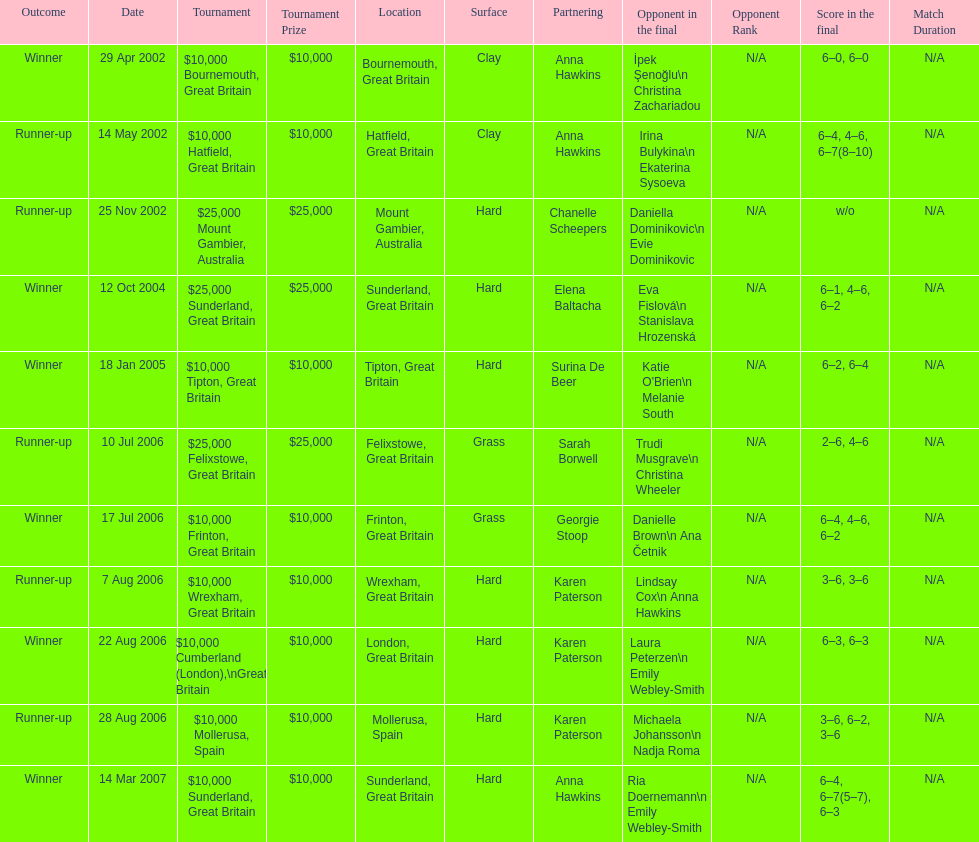What is the partnering name above chanelle scheepers? Anna Hawkins. Could you parse the entire table? {'header': ['Outcome', 'Date', 'Tournament', 'Tournament Prize', 'Location', 'Surface', 'Partnering', 'Opponent in the final', 'Opponent Rank', 'Score in the final', 'Match Duration'], 'rows': [['Winner', '29 Apr 2002', '$10,000 Bournemouth, Great Britain', '$10,000', 'Bournemouth, Great Britain', 'Clay', 'Anna Hawkins', 'İpek Şenoğlu\\n Christina Zachariadou', 'N/A', '6–0, 6–0', 'N/A'], ['Runner-up', '14 May 2002', '$10,000 Hatfield, Great Britain', '$10,000', 'Hatfield, Great Britain', 'Clay', 'Anna Hawkins', 'Irina Bulykina\\n Ekaterina Sysoeva', 'N/A', '6–4, 4–6, 6–7(8–10)', 'N/A'], ['Runner-up', '25 Nov 2002', '$25,000 Mount Gambier, Australia', '$25,000', 'Mount Gambier, Australia', 'Hard', 'Chanelle Scheepers', 'Daniella Dominikovic\\n Evie Dominikovic', 'N/A', 'w/o', 'N/A'], ['Winner', '12 Oct 2004', '$25,000 Sunderland, Great Britain', '$25,000', 'Sunderland, Great Britain', 'Hard', 'Elena Baltacha', 'Eva Fislová\\n Stanislava Hrozenská', 'N/A', '6–1, 4–6, 6–2', 'N/A'], ['Winner', '18 Jan 2005', '$10,000 Tipton, Great Britain', '$10,000', 'Tipton, Great Britain', 'Hard', 'Surina De Beer', "Katie O'Brien\\n Melanie South", 'N/A', '6–2, 6–4', 'N/A'], ['Runner-up', '10 Jul 2006', '$25,000 Felixstowe, Great Britain', '$25,000', 'Felixstowe, Great Britain', 'Grass', 'Sarah Borwell', 'Trudi Musgrave\\n Christina Wheeler', 'N/A', '2–6, 4–6', 'N/A'], ['Winner', '17 Jul 2006', '$10,000 Frinton, Great Britain', '$10,000', 'Frinton, Great Britain', 'Grass', 'Georgie Stoop', 'Danielle Brown\\n Ana Četnik', 'N/A', '6–4, 4–6, 6–2', 'N/A'], ['Runner-up', '7 Aug 2006', '$10,000 Wrexham, Great Britain', '$10,000', 'Wrexham, Great Britain', 'Hard', 'Karen Paterson', 'Lindsay Cox\\n Anna Hawkins', 'N/A', '3–6, 3–6', 'N/A'], ['Winner', '22 Aug 2006', '$10,000 Cumberland (London),\\nGreat Britain', '$10,000', 'London, Great Britain', 'Hard', 'Karen Paterson', 'Laura Peterzen\\n Emily Webley-Smith', 'N/A', '6–3, 6–3', 'N/A'], ['Runner-up', '28 Aug 2006', '$10,000 Mollerusa, Spain', '$10,000', 'Mollerusa, Spain', 'Hard', 'Karen Paterson', 'Michaela Johansson\\n Nadja Roma', 'N/A', '3–6, 6–2, 3–6', 'N/A'], ['Winner', '14 Mar 2007', '$10,000 Sunderland, Great Britain', '$10,000', 'Sunderland, Great Britain', 'Hard', 'Anna Hawkins', 'Ria Doernemann\\n Emily Webley-Smith', 'N/A', '6–4, 6–7(5–7), 6–3', 'N/A']]} 